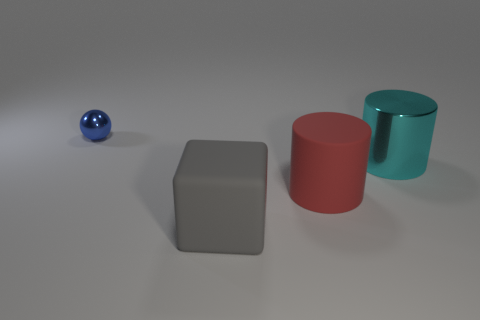Are there any other things that have the same size as the blue shiny ball?
Offer a very short reply. No. Is the number of big gray blocks that are to the left of the tiny blue object the same as the number of big blocks that are left of the large red thing?
Your answer should be compact. No. How many cubes are the same color as the shiny cylinder?
Provide a succinct answer. 0. What number of shiny objects are either large blocks or small spheres?
Make the answer very short. 1. Does the rubber object in front of the matte cylinder have the same shape as the metallic object that is to the left of the big matte cylinder?
Keep it short and to the point. No. There is a red object; what number of red cylinders are behind it?
Provide a short and direct response. 0. Is there a big gray object that has the same material as the red object?
Your answer should be compact. Yes. What material is the red cylinder that is the same size as the gray matte object?
Your answer should be compact. Rubber. Does the cyan cylinder have the same material as the large gray object?
Provide a succinct answer. No. How many objects are either tiny blue metallic objects or small cyan shiny spheres?
Provide a short and direct response. 1. 